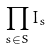Convert formula to latex. <formula><loc_0><loc_0><loc_500><loc_500>\prod _ { s \in S } I _ { s }</formula> 